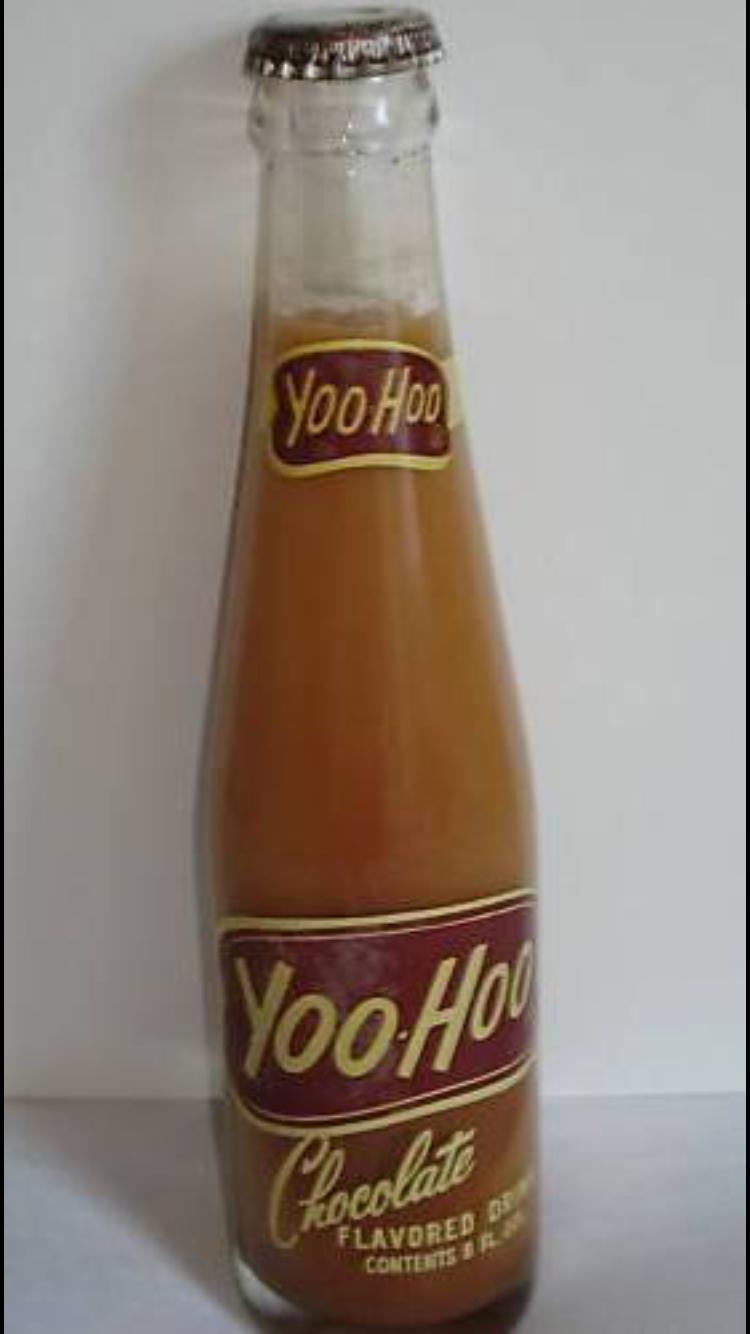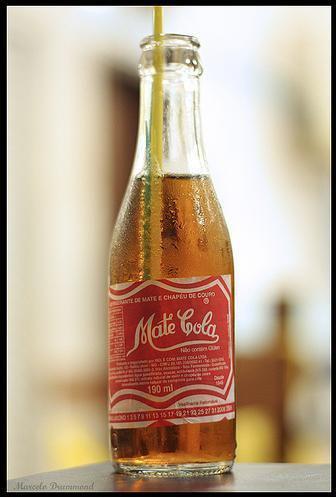The first image is the image on the left, the second image is the image on the right. Assess this claim about the two images: "One bottle is capped and one is not, at least one bottle is brown glass, at least one bottle is empty, and all bottles are beverage bottles.". Correct or not? Answer yes or no. No. The first image is the image on the left, the second image is the image on the right. Evaluate the accuracy of this statement regarding the images: "there is an amber colored empty bottle with no cap on". Is it true? Answer yes or no. No. 